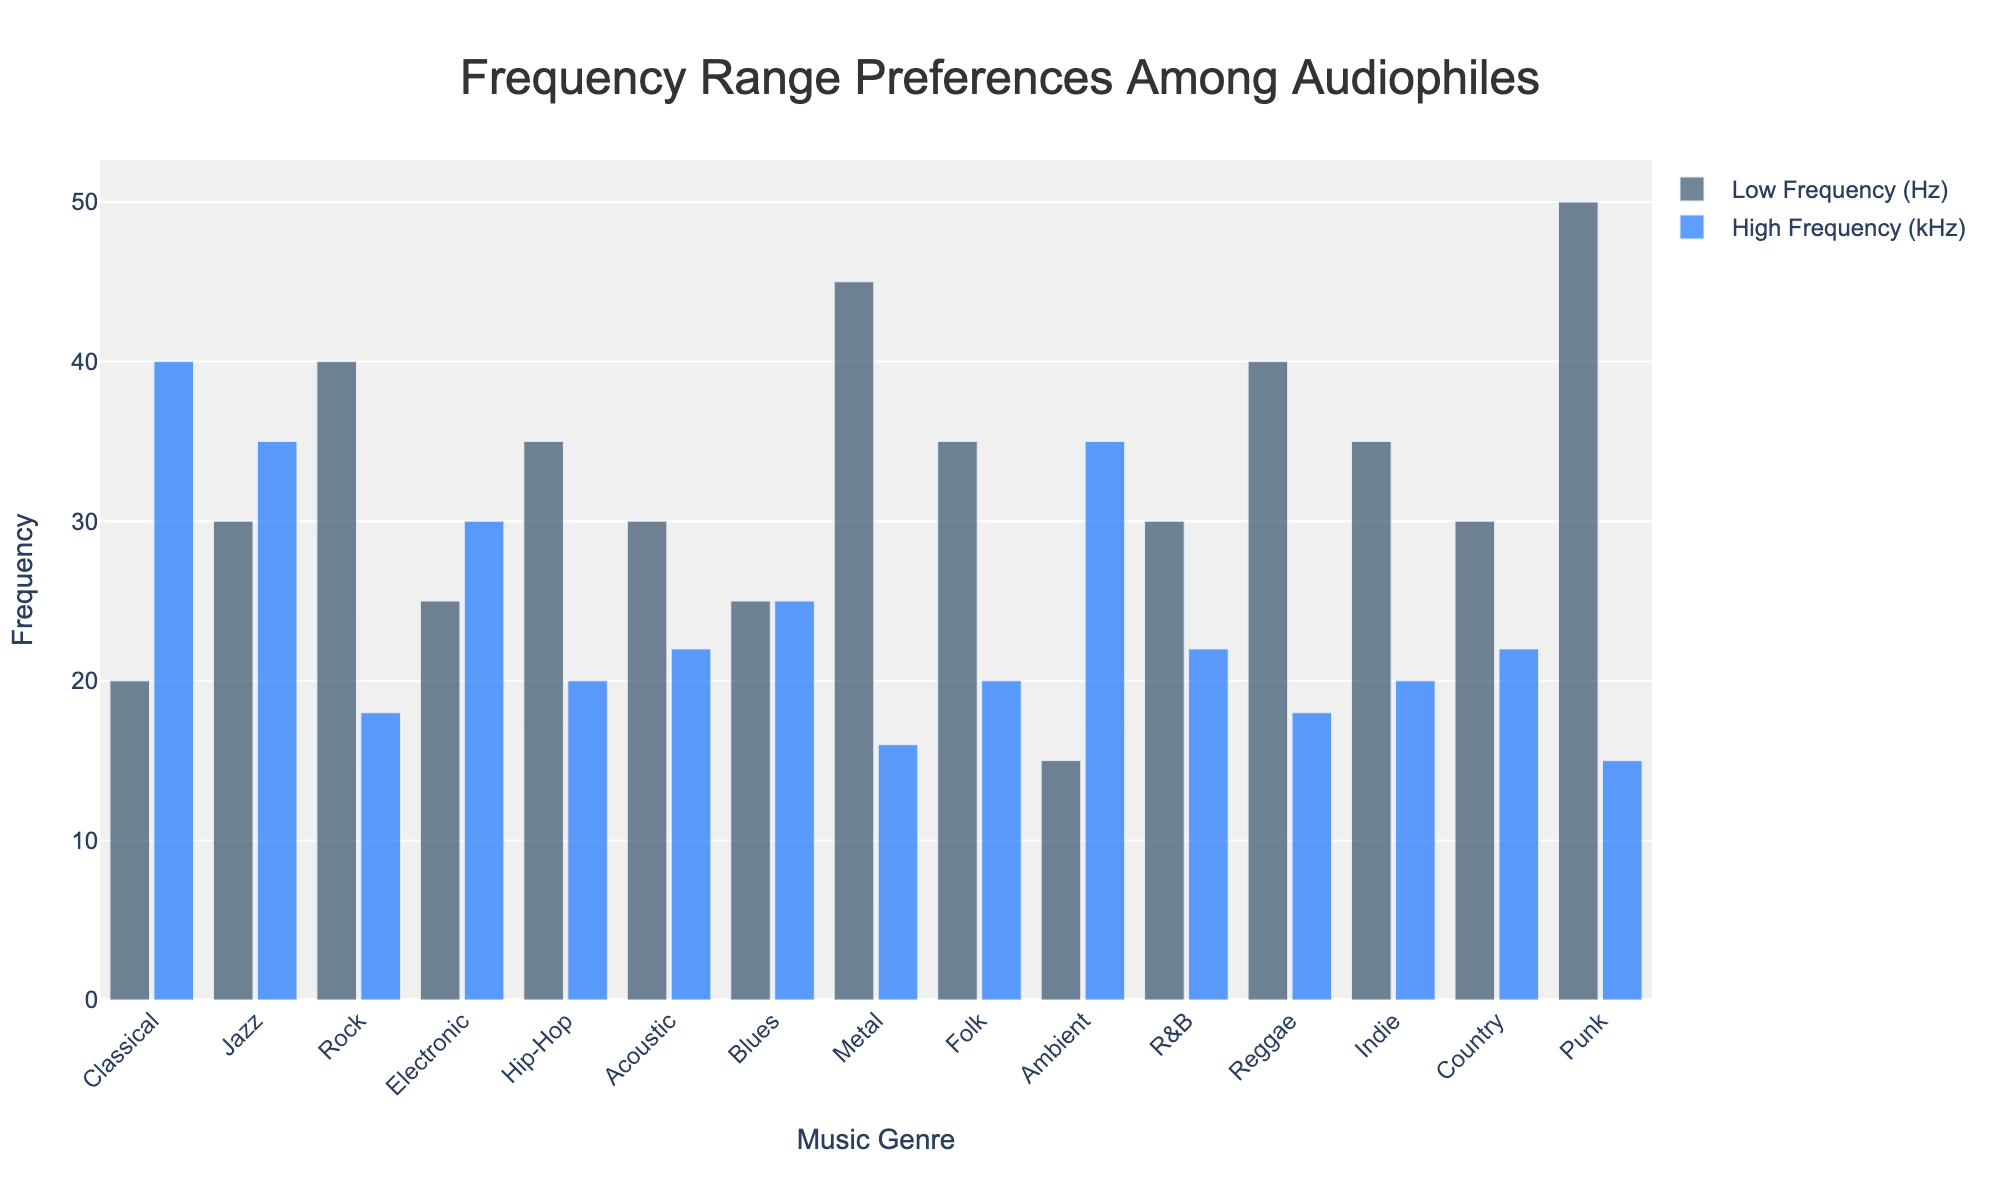What genre has the highest low frequency preference? The bar representing the low frequency preferences for all genres shows that Punk has the highest value among them.
Answer: Punk Compare the high frequency preferences for Jazz and Ambient genres. Which one is higher? The high frequency bar for Jazz is at 35 kHz, whereas for Ambient it is also at 35 kHz. Both are the same.
Answer: Both are the same What is the difference in the low frequency preference between Metal and Classical genres? The low frequency for Metal is 45 Hz, while for Classical it is 20 Hz. The difference is calculated by subtracting 20 from 45.
Answer: 25 Hz What's the average high frequency preference among Rock, Acoustic, and Indie genres? Add the high frequencies for Rock (18 kHz), Acoustic (22 kHz), and Indie (20 kHz), which equals 60 kHz. Then, divide by 3 to find the average: 60/3.
Answer: 20 kHz Which genre has both the highest low frequency and the lowest high frequency preferences? By observing the bars, Punk has the highest low frequency (50 Hz) and also has the lowest high frequency (15 kHz).
Answer: Punk Is there any genre that has the same low and high frequency preferences? By looking at both low and high frequency bars for all genres, no genre has exactly the same value for both.
Answer: No How much higher is the low frequency for Rock compared to its high frequency? The low frequency for Rock is 40 Hz and the high frequency is 18 kHz. Subtracting the high frequency value from the low frequency value gives 40 - 18.
Answer: 22 What genre has the second highest high frequency preference? The highest high frequency preference is Classical at 40 kHz. The second highest is Jazz and Ambient both at 35 kHz.
Answer: Jazz, Ambient What is the frequency range covered by the Electronic genre? The low frequency for Electronic is 25 Hz and the high frequency is 30 kHz. The range is calculated by subtracting the low frequency from the high frequency: 30 - 0.025.
Answer: 29.975 kHz Compare the high frequency preference for Blues with Low Frequency preference for Hip-Hop. Which one is higher? The high frequency for Blues is 25 kHz, while the low frequency for Hip-Hop is 35 Hz. Since 25 kHz is much higher than 35 Hz.
Answer: Blues 